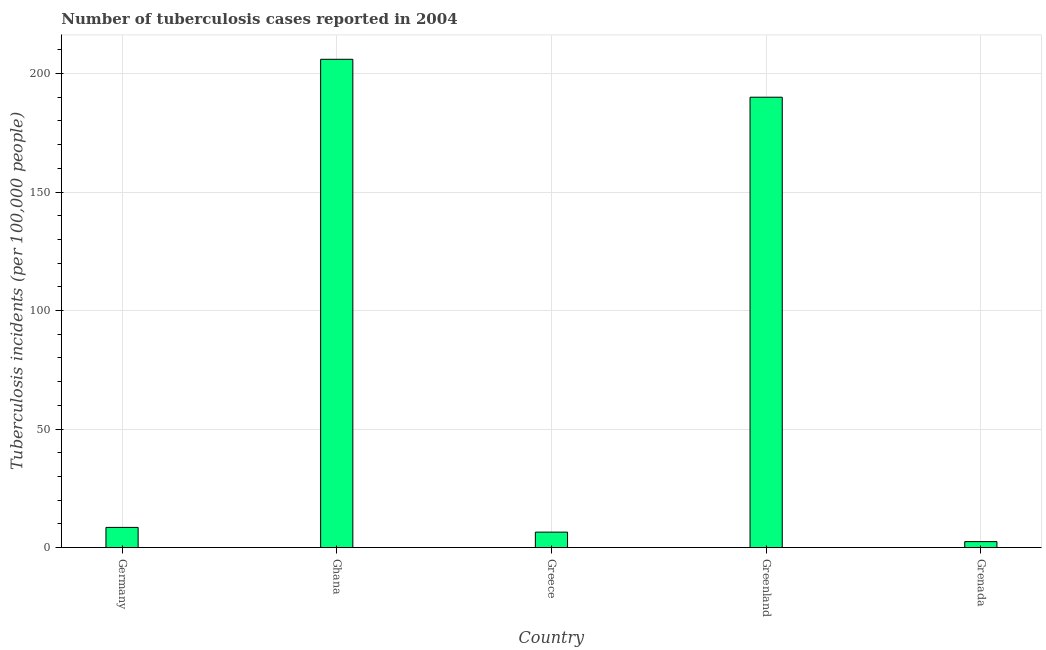Does the graph contain grids?
Give a very brief answer. Yes. What is the title of the graph?
Your answer should be very brief. Number of tuberculosis cases reported in 2004. What is the label or title of the X-axis?
Give a very brief answer. Country. What is the label or title of the Y-axis?
Provide a short and direct response. Tuberculosis incidents (per 100,0 people). What is the number of tuberculosis incidents in Greenland?
Your answer should be compact. 190. Across all countries, what is the maximum number of tuberculosis incidents?
Provide a succinct answer. 206. In which country was the number of tuberculosis incidents minimum?
Keep it short and to the point. Grenada. What is the sum of the number of tuberculosis incidents?
Make the answer very short. 413.5. What is the difference between the number of tuberculosis incidents in Ghana and Grenada?
Your answer should be compact. 203.5. What is the average number of tuberculosis incidents per country?
Provide a succinct answer. 82.7. What is the median number of tuberculosis incidents?
Your response must be concise. 8.5. In how many countries, is the number of tuberculosis incidents greater than 40 ?
Your answer should be compact. 2. What is the ratio of the number of tuberculosis incidents in Ghana to that in Greenland?
Provide a short and direct response. 1.08. Is the number of tuberculosis incidents in Greece less than that in Grenada?
Offer a terse response. No. What is the difference between the highest and the lowest number of tuberculosis incidents?
Keep it short and to the point. 203.5. What is the Tuberculosis incidents (per 100,000 people) in Germany?
Provide a succinct answer. 8.5. What is the Tuberculosis incidents (per 100,000 people) in Ghana?
Your answer should be very brief. 206. What is the Tuberculosis incidents (per 100,000 people) of Greenland?
Your response must be concise. 190. What is the Tuberculosis incidents (per 100,000 people) in Grenada?
Keep it short and to the point. 2.5. What is the difference between the Tuberculosis incidents (per 100,000 people) in Germany and Ghana?
Ensure brevity in your answer.  -197.5. What is the difference between the Tuberculosis incidents (per 100,000 people) in Germany and Greece?
Your response must be concise. 2. What is the difference between the Tuberculosis incidents (per 100,000 people) in Germany and Greenland?
Provide a short and direct response. -181.5. What is the difference between the Tuberculosis incidents (per 100,000 people) in Ghana and Greece?
Provide a short and direct response. 199.5. What is the difference between the Tuberculosis incidents (per 100,000 people) in Ghana and Grenada?
Your answer should be compact. 203.5. What is the difference between the Tuberculosis incidents (per 100,000 people) in Greece and Greenland?
Your response must be concise. -183.5. What is the difference between the Tuberculosis incidents (per 100,000 people) in Greenland and Grenada?
Your answer should be compact. 187.5. What is the ratio of the Tuberculosis incidents (per 100,000 people) in Germany to that in Ghana?
Your answer should be compact. 0.04. What is the ratio of the Tuberculosis incidents (per 100,000 people) in Germany to that in Greece?
Keep it short and to the point. 1.31. What is the ratio of the Tuberculosis incidents (per 100,000 people) in Germany to that in Greenland?
Make the answer very short. 0.04. What is the ratio of the Tuberculosis incidents (per 100,000 people) in Ghana to that in Greece?
Keep it short and to the point. 31.69. What is the ratio of the Tuberculosis incidents (per 100,000 people) in Ghana to that in Greenland?
Your response must be concise. 1.08. What is the ratio of the Tuberculosis incidents (per 100,000 people) in Ghana to that in Grenada?
Offer a terse response. 82.4. What is the ratio of the Tuberculosis incidents (per 100,000 people) in Greece to that in Greenland?
Keep it short and to the point. 0.03. What is the ratio of the Tuberculosis incidents (per 100,000 people) in Greenland to that in Grenada?
Offer a terse response. 76. 